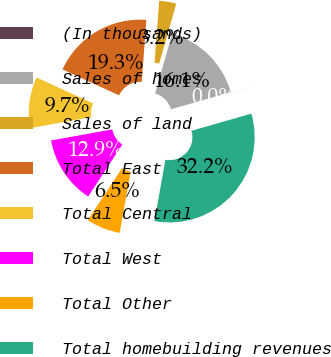Convert chart. <chart><loc_0><loc_0><loc_500><loc_500><pie_chart><fcel>(In thousands)<fcel>Sales of homes<fcel>Sales of land<fcel>Total East<fcel>Total Central<fcel>Total West<fcel>Total Other<fcel>Total homebuilding revenues<nl><fcel>0.01%<fcel>16.13%<fcel>3.23%<fcel>19.35%<fcel>9.68%<fcel>12.9%<fcel>6.46%<fcel>32.25%<nl></chart> 